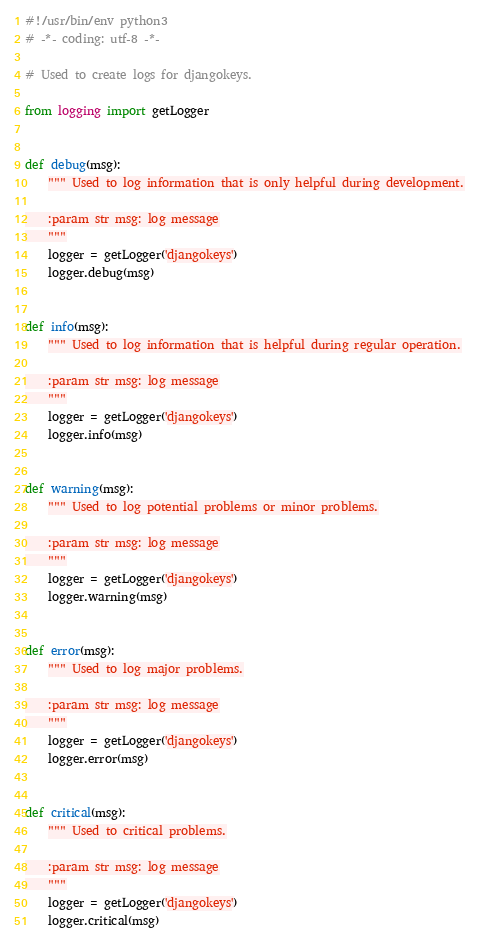<code> <loc_0><loc_0><loc_500><loc_500><_Python_>#!/usr/bin/env python3
# -*- coding: utf-8 -*-

# Used to create logs for djangokeys.

from logging import getLogger


def debug(msg):
    """ Used to log information that is only helpful during development.

    :param str msg: log message
    """
    logger = getLogger('djangokeys')
    logger.debug(msg)


def info(msg):
    """ Used to log information that is helpful during regular operation.

    :param str msg: log message
    """
    logger = getLogger('djangokeys')
    logger.info(msg)


def warning(msg):
    """ Used to log potential problems or minor problems.

    :param str msg: log message
    """
    logger = getLogger('djangokeys')
    logger.warning(msg)


def error(msg):
    """ Used to log major problems.

    :param str msg: log message
    """
    logger = getLogger('djangokeys')
    logger.error(msg)


def critical(msg):
    """ Used to critical problems.

    :param str msg: log message
    """
    logger = getLogger('djangokeys')
    logger.critical(msg)
</code> 